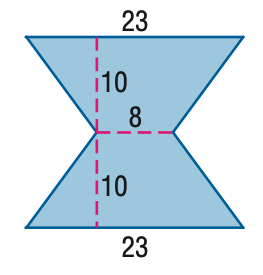Question: Find the area of the figure. Round to the nearest tenth if necessary.
Choices:
A. 210
B. 230
C. 310
D. 460
Answer with the letter. Answer: C 